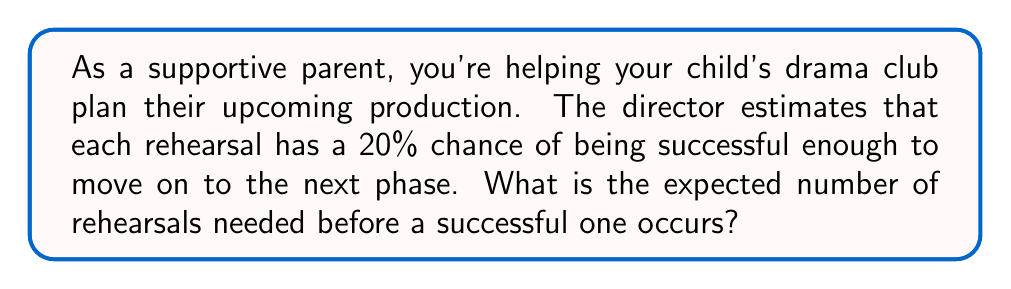What is the answer to this math problem? Let's approach this step-by-step:

1) This scenario follows a geometric distribution, where we're looking for the expected number of trials (rehearsals) before the first success.

2) In a geometric distribution, the probability of success on any given trial is constant. Let's call this probability $p$. In this case, $p = 0.20$ or 20%.

3) The expected value (mean) of a geometric distribution is given by the formula:

   $$E(X) = \frac{1}{p}$$

4) Substituting our value of $p$:

   $$E(X) = \frac{1}{0.20} = 5$$

5) Therefore, the expected number of rehearsals needed is 5.

This means that, on average, the drama club should expect to have 5 rehearsals before achieving a successful one. As a supportive parent, you can help your child understand that multiple rehearsals are a normal part of the process and contribute to the overall quality of the production.
Answer: 5 rehearsals 